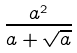<formula> <loc_0><loc_0><loc_500><loc_500>\frac { a ^ { 2 } } { a + \sqrt { a } }</formula> 